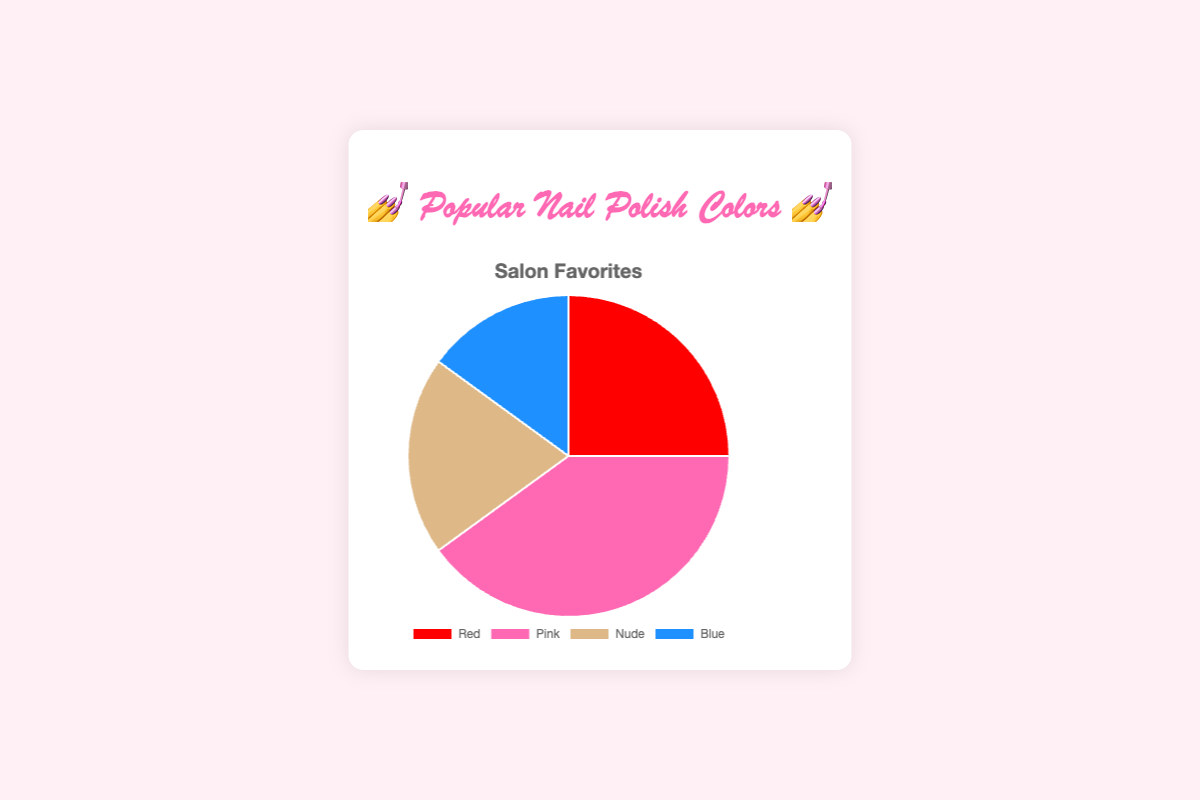Which nail polish color is the most popular in the salon? The segment with the largest portion of the pie chart represents the most popular color. Here, the largest segment is Pink, which has the highest percentage (40%).
Answer: Pink What is the least popular nail polish color? The smallest segment in the pie chart represents the least popular color. Here, the smallest segment is Blue with 15%.
Answer: Blue What is the combined percentage of Red and Nude nail polish colors? To get the combined percentage, sum up the individual percentages of Red and Nude. Red is 25% and Nude is 20%, so the total is 25% + 20% = 45%.
Answer: 45% How does the popularity of Blue compare to Nude? To compare, look at the percentages of Blue and Nude. Blue is 15% and Nude is 20%, so Nude is more popular than Blue by 5%.
Answer: Nude is more popular by 5% Which colors together make up more than half of the total percentage? Start by adding the top percentages until you exceed 50%. Pink (40%) and Red (25%) together make up 65%, which is more than half.
Answer: Pink and Red What's the difference in percentage between the most and least popular colors? Subtract the percentage of the least popular color (Blue, 15%) from the most popular color (Pink, 40%). The difference is 40% - 15% = 25%.
Answer: 25% If you combine the percentages of Red and Blue, do they match or exceed the percentage of Pink? Add the percentages of Red (25%) and Blue (15%) to see if they match or exceed Pink's percentage (40%). Red + Blue = 25% + 15% = 40%, which matches Pink's percentage.
Answer: Matches Pink Which color has a 20% representation in the pie chart? Look at the segment that represents 20%. Nude has a 20% representation in the pie chart.
Answer: Nude What is the average percentage of all four nail polish colors? Sum the percentages of all four colors and then divide by 4. The total percentage is 25% (Red) + 40% (Pink) + 20% (Nude) + 15% (Blue) = 100%. The average is 100% / 4 = 25%.
Answer: 25% 